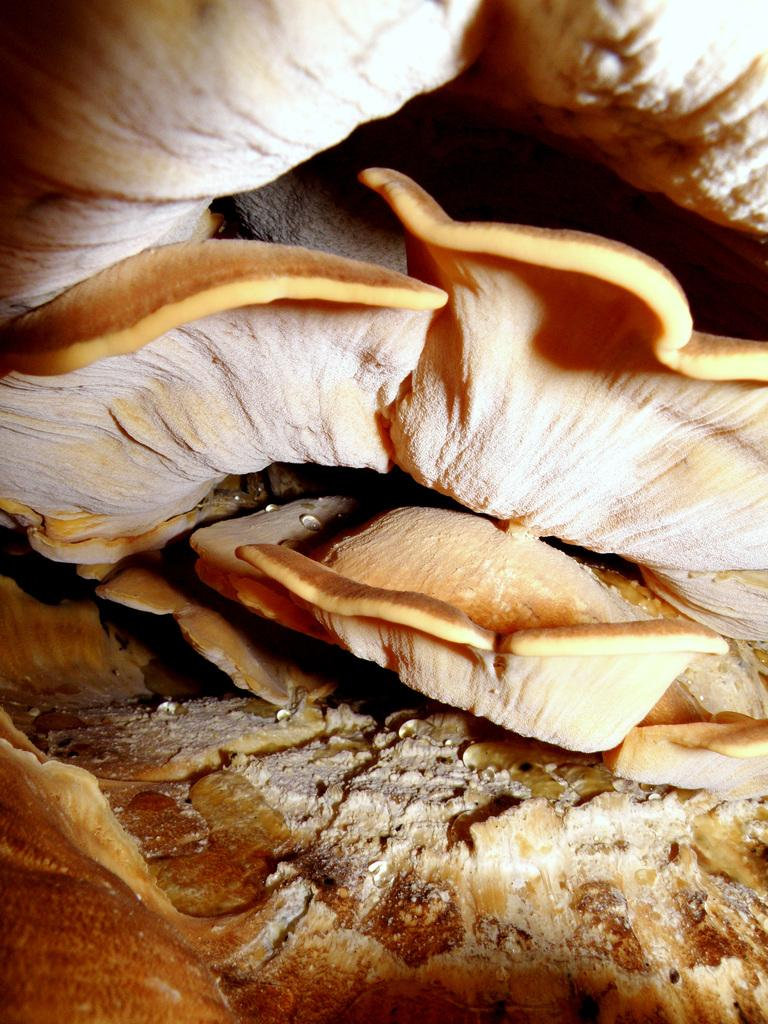What type of fungi can be seen in the image? There is a mushroom in the image. Is the mushroom stuck in quicksand in the image? There is no quicksand present in the image, and the mushroom is not depicted as being stuck in any substance. What type of transportation is used to move the mushroom in the image? There is no transportation present in the image, and the mushroom is not depicted as being moved by any means. 